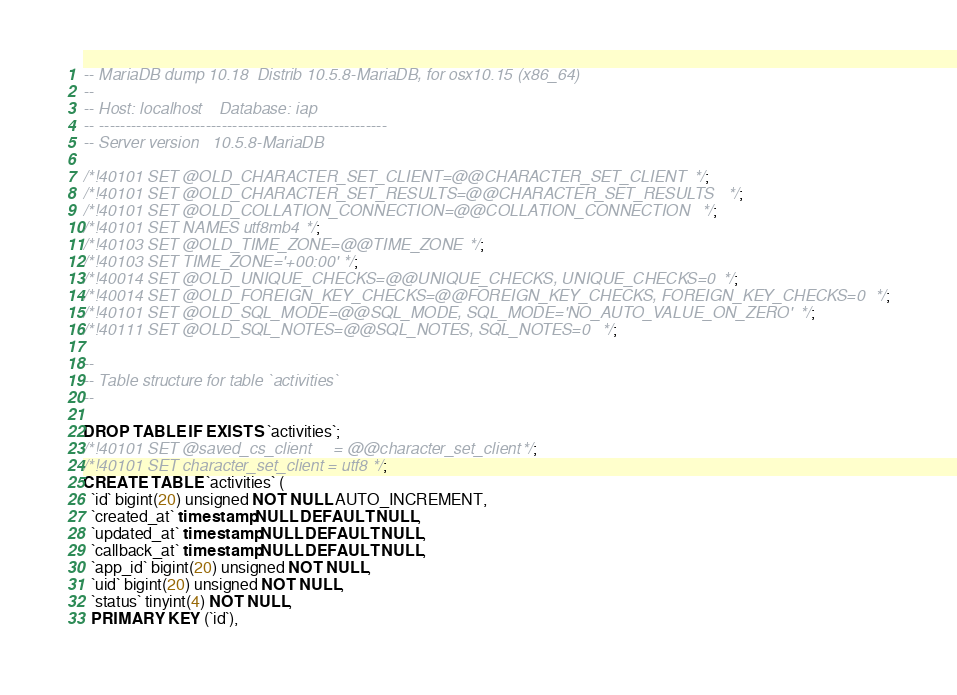Convert code to text. <code><loc_0><loc_0><loc_500><loc_500><_SQL_>-- MariaDB dump 10.18  Distrib 10.5.8-MariaDB, for osx10.15 (x86_64)
--
-- Host: localhost    Database: iap
-- ------------------------------------------------------
-- Server version	10.5.8-MariaDB

/*!40101 SET @OLD_CHARACTER_SET_CLIENT=@@CHARACTER_SET_CLIENT */;
/*!40101 SET @OLD_CHARACTER_SET_RESULTS=@@CHARACTER_SET_RESULTS */;
/*!40101 SET @OLD_COLLATION_CONNECTION=@@COLLATION_CONNECTION */;
/*!40101 SET NAMES utf8mb4 */;
/*!40103 SET @OLD_TIME_ZONE=@@TIME_ZONE */;
/*!40103 SET TIME_ZONE='+00:00' */;
/*!40014 SET @OLD_UNIQUE_CHECKS=@@UNIQUE_CHECKS, UNIQUE_CHECKS=0 */;
/*!40014 SET @OLD_FOREIGN_KEY_CHECKS=@@FOREIGN_KEY_CHECKS, FOREIGN_KEY_CHECKS=0 */;
/*!40101 SET @OLD_SQL_MODE=@@SQL_MODE, SQL_MODE='NO_AUTO_VALUE_ON_ZERO' */;
/*!40111 SET @OLD_SQL_NOTES=@@SQL_NOTES, SQL_NOTES=0 */;

--
-- Table structure for table `activities`
--

DROP TABLE IF EXISTS `activities`;
/*!40101 SET @saved_cs_client     = @@character_set_client */;
/*!40101 SET character_set_client = utf8 */;
CREATE TABLE `activities` (
  `id` bigint(20) unsigned NOT NULL AUTO_INCREMENT,
  `created_at` timestamp NULL DEFAULT NULL,
  `updated_at` timestamp NULL DEFAULT NULL,
  `callback_at` timestamp NULL DEFAULT NULL,
  `app_id` bigint(20) unsigned NOT NULL,
  `uid` bigint(20) unsigned NOT NULL,
  `status` tinyint(4) NOT NULL,
  PRIMARY KEY (`id`),</code> 